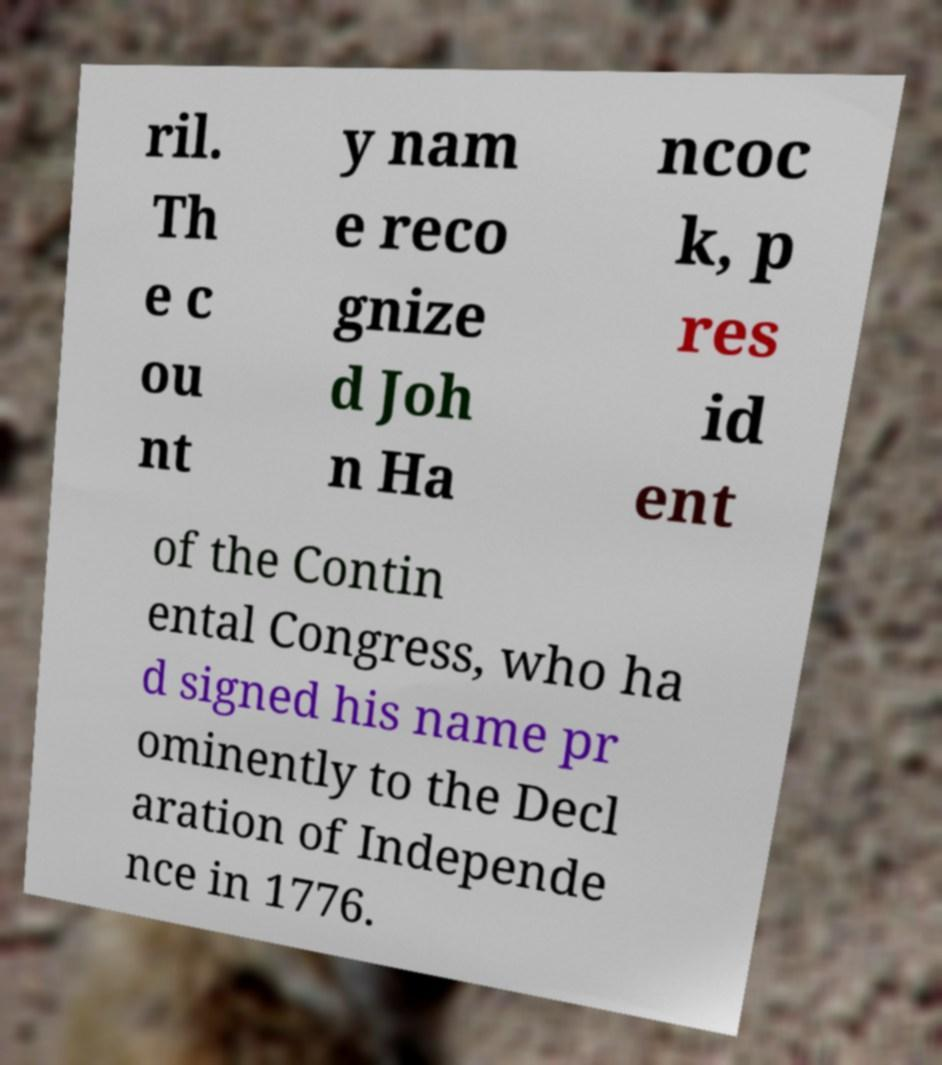There's text embedded in this image that I need extracted. Can you transcribe it verbatim? ril. Th e c ou nt y nam e reco gnize d Joh n Ha ncoc k, p res id ent of the Contin ental Congress, who ha d signed his name pr ominently to the Decl aration of Independe nce in 1776. 